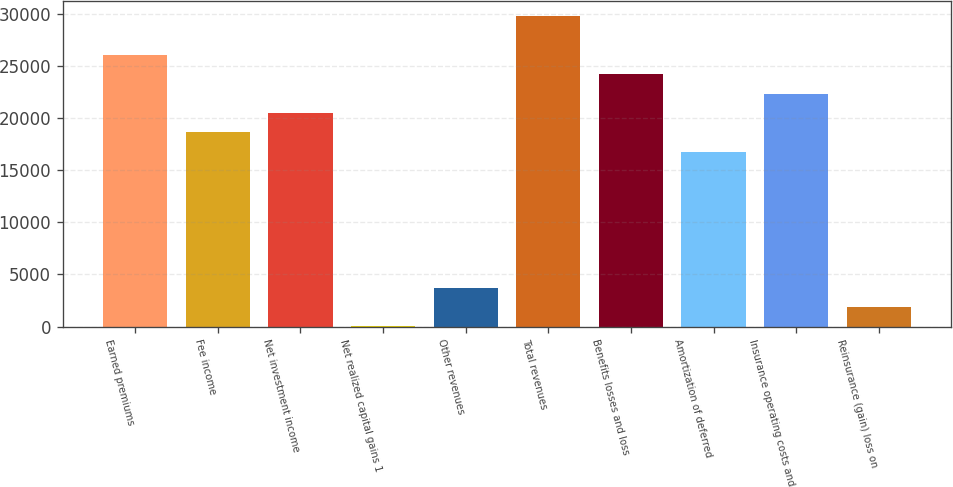Convert chart to OTSL. <chart><loc_0><loc_0><loc_500><loc_500><bar_chart><fcel>Earned premiums<fcel>Fee income<fcel>Net investment income<fcel>Net realized capital gains 1<fcel>Other revenues<fcel>Total revenues<fcel>Benefits losses and loss<fcel>Amortization of deferred<fcel>Insurance operating costs and<fcel>Reinsurance (gain) loss on<nl><fcel>26053.2<fcel>18614<fcel>20473.8<fcel>16<fcel>3735.6<fcel>29772.8<fcel>24193.4<fcel>16754.2<fcel>22333.6<fcel>1875.8<nl></chart> 